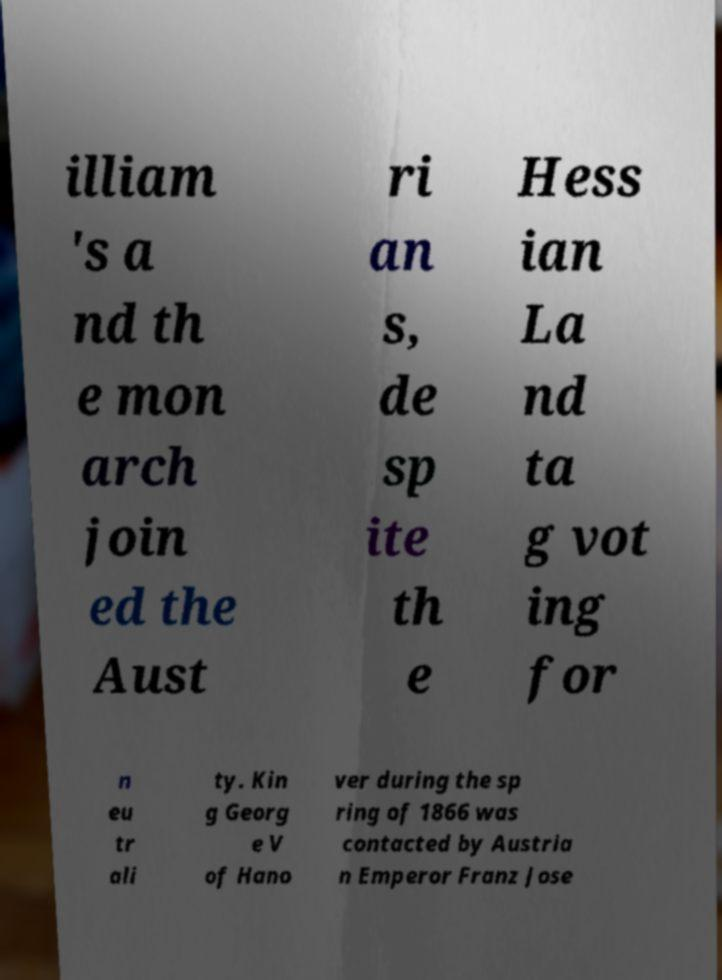Please identify and transcribe the text found in this image. illiam 's a nd th e mon arch join ed the Aust ri an s, de sp ite th e Hess ian La nd ta g vot ing for n eu tr ali ty. Kin g Georg e V of Hano ver during the sp ring of 1866 was contacted by Austria n Emperor Franz Jose 